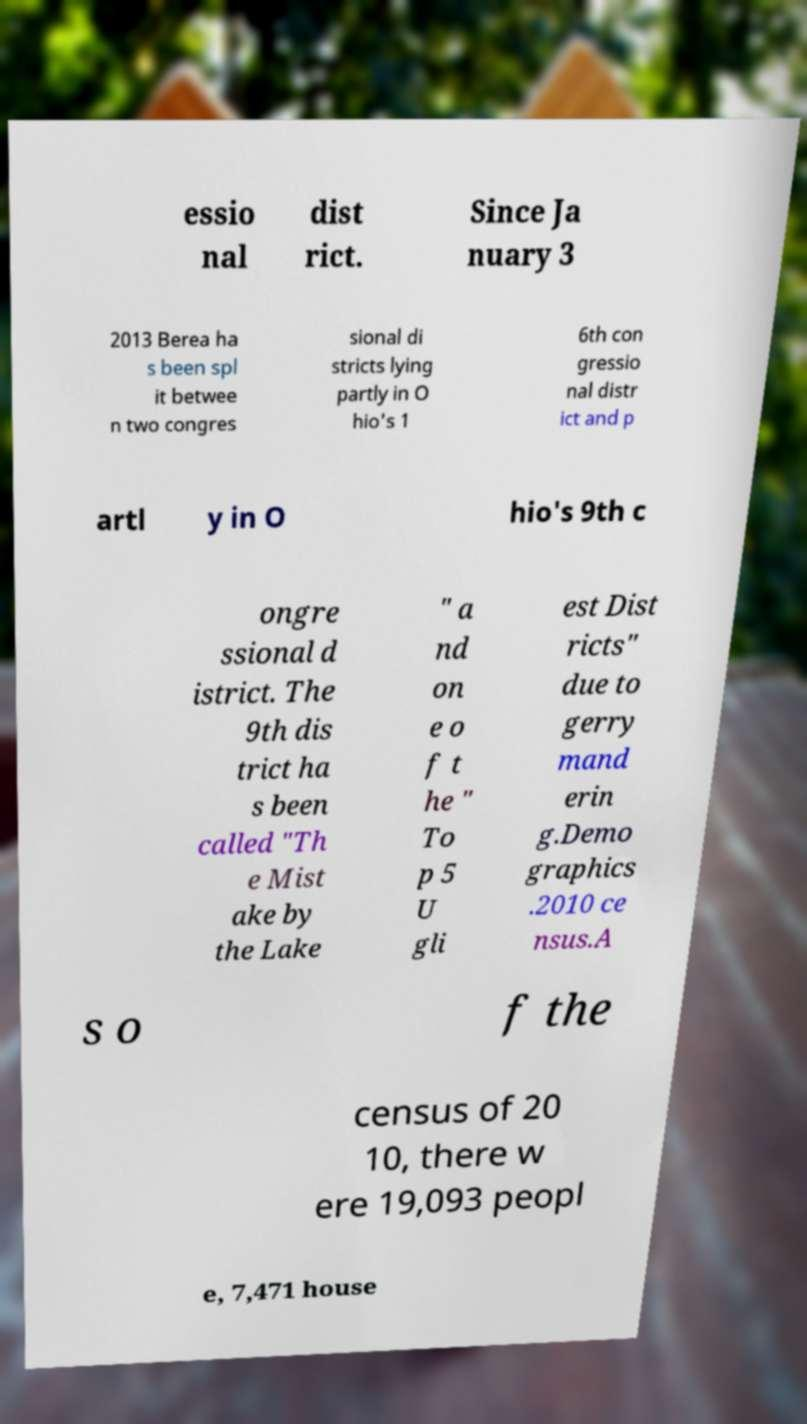Can you read and provide the text displayed in the image?This photo seems to have some interesting text. Can you extract and type it out for me? essio nal dist rict. Since Ja nuary 3 2013 Berea ha s been spl it betwee n two congres sional di stricts lying partly in O hio's 1 6th con gressio nal distr ict and p artl y in O hio's 9th c ongre ssional d istrict. The 9th dis trict ha s been called "Th e Mist ake by the Lake " a nd on e o f t he " To p 5 U gli est Dist ricts" due to gerry mand erin g.Demo graphics .2010 ce nsus.A s o f the census of 20 10, there w ere 19,093 peopl e, 7,471 house 